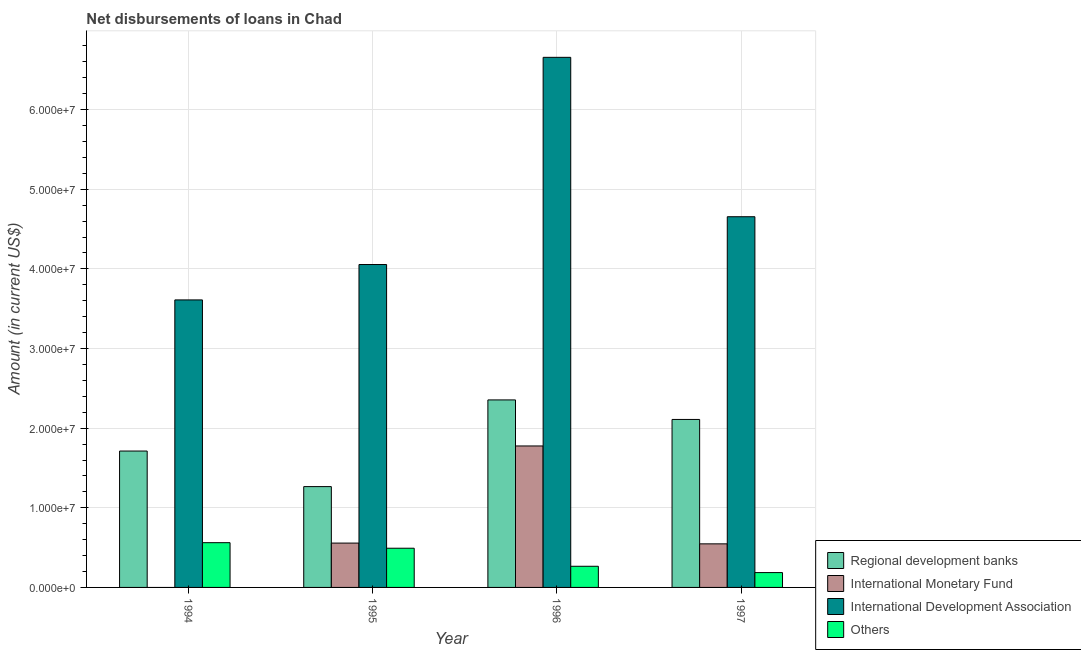Are the number of bars per tick equal to the number of legend labels?
Offer a very short reply. No. How many bars are there on the 4th tick from the left?
Your answer should be very brief. 4. How many bars are there on the 1st tick from the right?
Your response must be concise. 4. In how many cases, is the number of bars for a given year not equal to the number of legend labels?
Keep it short and to the point. 1. What is the amount of loan disimbursed by international development association in 1994?
Give a very brief answer. 3.61e+07. Across all years, what is the maximum amount of loan disimbursed by international development association?
Your response must be concise. 6.66e+07. Across all years, what is the minimum amount of loan disimbursed by international development association?
Keep it short and to the point. 3.61e+07. In which year was the amount of loan disimbursed by regional development banks maximum?
Provide a short and direct response. 1996. What is the total amount of loan disimbursed by international monetary fund in the graph?
Ensure brevity in your answer.  2.88e+07. What is the difference between the amount of loan disimbursed by international monetary fund in 1996 and that in 1997?
Your answer should be compact. 1.23e+07. What is the difference between the amount of loan disimbursed by international monetary fund in 1994 and the amount of loan disimbursed by international development association in 1996?
Your answer should be compact. -1.78e+07. What is the average amount of loan disimbursed by regional development banks per year?
Your response must be concise. 1.86e+07. In how many years, is the amount of loan disimbursed by other organisations greater than 28000000 US$?
Provide a succinct answer. 0. What is the ratio of the amount of loan disimbursed by other organisations in 1995 to that in 1997?
Your answer should be very brief. 2.64. Is the amount of loan disimbursed by regional development banks in 1995 less than that in 1996?
Your response must be concise. Yes. Is the difference between the amount of loan disimbursed by other organisations in 1996 and 1997 greater than the difference between the amount of loan disimbursed by international monetary fund in 1996 and 1997?
Provide a succinct answer. No. What is the difference between the highest and the second highest amount of loan disimbursed by international development association?
Provide a succinct answer. 2.00e+07. What is the difference between the highest and the lowest amount of loan disimbursed by regional development banks?
Keep it short and to the point. 1.09e+07. Is the sum of the amount of loan disimbursed by international development association in 1995 and 1996 greater than the maximum amount of loan disimbursed by regional development banks across all years?
Give a very brief answer. Yes. Is it the case that in every year, the sum of the amount of loan disimbursed by international monetary fund and amount of loan disimbursed by other organisations is greater than the sum of amount of loan disimbursed by regional development banks and amount of loan disimbursed by international development association?
Make the answer very short. No. How many bars are there?
Ensure brevity in your answer.  15. Are all the bars in the graph horizontal?
Give a very brief answer. No. What is the difference between two consecutive major ticks on the Y-axis?
Provide a succinct answer. 1.00e+07. Does the graph contain any zero values?
Give a very brief answer. Yes. Does the graph contain grids?
Keep it short and to the point. Yes. Where does the legend appear in the graph?
Offer a very short reply. Bottom right. How many legend labels are there?
Provide a short and direct response. 4. What is the title of the graph?
Your response must be concise. Net disbursements of loans in Chad. What is the label or title of the Y-axis?
Your response must be concise. Amount (in current US$). What is the Amount (in current US$) of Regional development banks in 1994?
Provide a short and direct response. 1.71e+07. What is the Amount (in current US$) in International Monetary Fund in 1994?
Give a very brief answer. 0. What is the Amount (in current US$) of International Development Association in 1994?
Your response must be concise. 3.61e+07. What is the Amount (in current US$) of Others in 1994?
Offer a terse response. 5.62e+06. What is the Amount (in current US$) in Regional development banks in 1995?
Offer a very short reply. 1.27e+07. What is the Amount (in current US$) in International Monetary Fund in 1995?
Ensure brevity in your answer.  5.57e+06. What is the Amount (in current US$) in International Development Association in 1995?
Your response must be concise. 4.05e+07. What is the Amount (in current US$) of Others in 1995?
Offer a terse response. 4.92e+06. What is the Amount (in current US$) in Regional development banks in 1996?
Ensure brevity in your answer.  2.35e+07. What is the Amount (in current US$) in International Monetary Fund in 1996?
Make the answer very short. 1.78e+07. What is the Amount (in current US$) in International Development Association in 1996?
Offer a very short reply. 6.66e+07. What is the Amount (in current US$) of Others in 1996?
Offer a terse response. 2.66e+06. What is the Amount (in current US$) of Regional development banks in 1997?
Your answer should be compact. 2.11e+07. What is the Amount (in current US$) of International Monetary Fund in 1997?
Your answer should be very brief. 5.47e+06. What is the Amount (in current US$) in International Development Association in 1997?
Provide a succinct answer. 4.66e+07. What is the Amount (in current US$) in Others in 1997?
Ensure brevity in your answer.  1.86e+06. Across all years, what is the maximum Amount (in current US$) of Regional development banks?
Offer a very short reply. 2.35e+07. Across all years, what is the maximum Amount (in current US$) in International Monetary Fund?
Make the answer very short. 1.78e+07. Across all years, what is the maximum Amount (in current US$) in International Development Association?
Give a very brief answer. 6.66e+07. Across all years, what is the maximum Amount (in current US$) in Others?
Your answer should be very brief. 5.62e+06. Across all years, what is the minimum Amount (in current US$) of Regional development banks?
Provide a succinct answer. 1.27e+07. Across all years, what is the minimum Amount (in current US$) in International Development Association?
Your answer should be very brief. 3.61e+07. Across all years, what is the minimum Amount (in current US$) of Others?
Offer a terse response. 1.86e+06. What is the total Amount (in current US$) of Regional development banks in the graph?
Your response must be concise. 7.44e+07. What is the total Amount (in current US$) in International Monetary Fund in the graph?
Your answer should be compact. 2.88e+07. What is the total Amount (in current US$) in International Development Association in the graph?
Offer a very short reply. 1.90e+08. What is the total Amount (in current US$) of Others in the graph?
Keep it short and to the point. 1.51e+07. What is the difference between the Amount (in current US$) in Regional development banks in 1994 and that in 1995?
Your response must be concise. 4.47e+06. What is the difference between the Amount (in current US$) in International Development Association in 1994 and that in 1995?
Provide a succinct answer. -4.44e+06. What is the difference between the Amount (in current US$) of Others in 1994 and that in 1995?
Ensure brevity in your answer.  6.97e+05. What is the difference between the Amount (in current US$) of Regional development banks in 1994 and that in 1996?
Make the answer very short. -6.42e+06. What is the difference between the Amount (in current US$) in International Development Association in 1994 and that in 1996?
Keep it short and to the point. -3.05e+07. What is the difference between the Amount (in current US$) of Others in 1994 and that in 1996?
Your answer should be very brief. 2.96e+06. What is the difference between the Amount (in current US$) of Regional development banks in 1994 and that in 1997?
Your response must be concise. -3.97e+06. What is the difference between the Amount (in current US$) of International Development Association in 1994 and that in 1997?
Keep it short and to the point. -1.04e+07. What is the difference between the Amount (in current US$) of Others in 1994 and that in 1997?
Provide a succinct answer. 3.76e+06. What is the difference between the Amount (in current US$) in Regional development banks in 1995 and that in 1996?
Ensure brevity in your answer.  -1.09e+07. What is the difference between the Amount (in current US$) of International Monetary Fund in 1995 and that in 1996?
Keep it short and to the point. -1.22e+07. What is the difference between the Amount (in current US$) of International Development Association in 1995 and that in 1996?
Give a very brief answer. -2.60e+07. What is the difference between the Amount (in current US$) of Others in 1995 and that in 1996?
Keep it short and to the point. 2.27e+06. What is the difference between the Amount (in current US$) of Regional development banks in 1995 and that in 1997?
Your answer should be very brief. -8.43e+06. What is the difference between the Amount (in current US$) of International Monetary Fund in 1995 and that in 1997?
Provide a succinct answer. 9.60e+04. What is the difference between the Amount (in current US$) in International Development Association in 1995 and that in 1997?
Provide a succinct answer. -6.00e+06. What is the difference between the Amount (in current US$) in Others in 1995 and that in 1997?
Ensure brevity in your answer.  3.06e+06. What is the difference between the Amount (in current US$) of Regional development banks in 1996 and that in 1997?
Your answer should be very brief. 2.45e+06. What is the difference between the Amount (in current US$) in International Monetary Fund in 1996 and that in 1997?
Your response must be concise. 1.23e+07. What is the difference between the Amount (in current US$) of International Development Association in 1996 and that in 1997?
Provide a succinct answer. 2.00e+07. What is the difference between the Amount (in current US$) in Others in 1996 and that in 1997?
Your answer should be very brief. 7.94e+05. What is the difference between the Amount (in current US$) of Regional development banks in 1994 and the Amount (in current US$) of International Monetary Fund in 1995?
Ensure brevity in your answer.  1.16e+07. What is the difference between the Amount (in current US$) in Regional development banks in 1994 and the Amount (in current US$) in International Development Association in 1995?
Offer a terse response. -2.34e+07. What is the difference between the Amount (in current US$) of Regional development banks in 1994 and the Amount (in current US$) of Others in 1995?
Your answer should be compact. 1.22e+07. What is the difference between the Amount (in current US$) of International Development Association in 1994 and the Amount (in current US$) of Others in 1995?
Provide a succinct answer. 3.12e+07. What is the difference between the Amount (in current US$) of Regional development banks in 1994 and the Amount (in current US$) of International Monetary Fund in 1996?
Offer a terse response. -6.37e+05. What is the difference between the Amount (in current US$) in Regional development banks in 1994 and the Amount (in current US$) in International Development Association in 1996?
Your answer should be compact. -4.94e+07. What is the difference between the Amount (in current US$) of Regional development banks in 1994 and the Amount (in current US$) of Others in 1996?
Your response must be concise. 1.45e+07. What is the difference between the Amount (in current US$) in International Development Association in 1994 and the Amount (in current US$) in Others in 1996?
Make the answer very short. 3.34e+07. What is the difference between the Amount (in current US$) in Regional development banks in 1994 and the Amount (in current US$) in International Monetary Fund in 1997?
Your answer should be compact. 1.17e+07. What is the difference between the Amount (in current US$) of Regional development banks in 1994 and the Amount (in current US$) of International Development Association in 1997?
Give a very brief answer. -2.94e+07. What is the difference between the Amount (in current US$) of Regional development banks in 1994 and the Amount (in current US$) of Others in 1997?
Provide a succinct answer. 1.53e+07. What is the difference between the Amount (in current US$) in International Development Association in 1994 and the Amount (in current US$) in Others in 1997?
Your answer should be very brief. 3.42e+07. What is the difference between the Amount (in current US$) of Regional development banks in 1995 and the Amount (in current US$) of International Monetary Fund in 1996?
Ensure brevity in your answer.  -5.10e+06. What is the difference between the Amount (in current US$) of Regional development banks in 1995 and the Amount (in current US$) of International Development Association in 1996?
Ensure brevity in your answer.  -5.39e+07. What is the difference between the Amount (in current US$) of Regional development banks in 1995 and the Amount (in current US$) of Others in 1996?
Ensure brevity in your answer.  1.00e+07. What is the difference between the Amount (in current US$) of International Monetary Fund in 1995 and the Amount (in current US$) of International Development Association in 1996?
Give a very brief answer. -6.10e+07. What is the difference between the Amount (in current US$) of International Monetary Fund in 1995 and the Amount (in current US$) of Others in 1996?
Give a very brief answer. 2.91e+06. What is the difference between the Amount (in current US$) in International Development Association in 1995 and the Amount (in current US$) in Others in 1996?
Keep it short and to the point. 3.79e+07. What is the difference between the Amount (in current US$) of Regional development banks in 1995 and the Amount (in current US$) of International Monetary Fund in 1997?
Your response must be concise. 7.19e+06. What is the difference between the Amount (in current US$) in Regional development banks in 1995 and the Amount (in current US$) in International Development Association in 1997?
Offer a very short reply. -3.39e+07. What is the difference between the Amount (in current US$) of Regional development banks in 1995 and the Amount (in current US$) of Others in 1997?
Give a very brief answer. 1.08e+07. What is the difference between the Amount (in current US$) of International Monetary Fund in 1995 and the Amount (in current US$) of International Development Association in 1997?
Offer a terse response. -4.10e+07. What is the difference between the Amount (in current US$) in International Monetary Fund in 1995 and the Amount (in current US$) in Others in 1997?
Offer a terse response. 3.70e+06. What is the difference between the Amount (in current US$) of International Development Association in 1995 and the Amount (in current US$) of Others in 1997?
Your answer should be compact. 3.87e+07. What is the difference between the Amount (in current US$) in Regional development banks in 1996 and the Amount (in current US$) in International Monetary Fund in 1997?
Keep it short and to the point. 1.81e+07. What is the difference between the Amount (in current US$) of Regional development banks in 1996 and the Amount (in current US$) of International Development Association in 1997?
Provide a succinct answer. -2.30e+07. What is the difference between the Amount (in current US$) of Regional development banks in 1996 and the Amount (in current US$) of Others in 1997?
Offer a very short reply. 2.17e+07. What is the difference between the Amount (in current US$) of International Monetary Fund in 1996 and the Amount (in current US$) of International Development Association in 1997?
Your response must be concise. -2.88e+07. What is the difference between the Amount (in current US$) of International Monetary Fund in 1996 and the Amount (in current US$) of Others in 1997?
Provide a succinct answer. 1.59e+07. What is the difference between the Amount (in current US$) in International Development Association in 1996 and the Amount (in current US$) in Others in 1997?
Your answer should be compact. 6.47e+07. What is the average Amount (in current US$) in Regional development banks per year?
Offer a very short reply. 1.86e+07. What is the average Amount (in current US$) of International Monetary Fund per year?
Make the answer very short. 7.20e+06. What is the average Amount (in current US$) in International Development Association per year?
Your answer should be compact. 4.74e+07. What is the average Amount (in current US$) of Others per year?
Keep it short and to the point. 3.77e+06. In the year 1994, what is the difference between the Amount (in current US$) of Regional development banks and Amount (in current US$) of International Development Association?
Your answer should be compact. -1.90e+07. In the year 1994, what is the difference between the Amount (in current US$) in Regional development banks and Amount (in current US$) in Others?
Your answer should be very brief. 1.15e+07. In the year 1994, what is the difference between the Amount (in current US$) in International Development Association and Amount (in current US$) in Others?
Keep it short and to the point. 3.05e+07. In the year 1995, what is the difference between the Amount (in current US$) in Regional development banks and Amount (in current US$) in International Monetary Fund?
Your answer should be very brief. 7.09e+06. In the year 1995, what is the difference between the Amount (in current US$) of Regional development banks and Amount (in current US$) of International Development Association?
Your answer should be compact. -2.79e+07. In the year 1995, what is the difference between the Amount (in current US$) in Regional development banks and Amount (in current US$) in Others?
Ensure brevity in your answer.  7.74e+06. In the year 1995, what is the difference between the Amount (in current US$) of International Monetary Fund and Amount (in current US$) of International Development Association?
Provide a short and direct response. -3.50e+07. In the year 1995, what is the difference between the Amount (in current US$) of International Monetary Fund and Amount (in current US$) of Others?
Provide a succinct answer. 6.45e+05. In the year 1995, what is the difference between the Amount (in current US$) of International Development Association and Amount (in current US$) of Others?
Provide a short and direct response. 3.56e+07. In the year 1996, what is the difference between the Amount (in current US$) of Regional development banks and Amount (in current US$) of International Monetary Fund?
Give a very brief answer. 5.78e+06. In the year 1996, what is the difference between the Amount (in current US$) of Regional development banks and Amount (in current US$) of International Development Association?
Your response must be concise. -4.30e+07. In the year 1996, what is the difference between the Amount (in current US$) of Regional development banks and Amount (in current US$) of Others?
Your answer should be very brief. 2.09e+07. In the year 1996, what is the difference between the Amount (in current US$) of International Monetary Fund and Amount (in current US$) of International Development Association?
Give a very brief answer. -4.88e+07. In the year 1996, what is the difference between the Amount (in current US$) in International Monetary Fund and Amount (in current US$) in Others?
Your answer should be very brief. 1.51e+07. In the year 1996, what is the difference between the Amount (in current US$) in International Development Association and Amount (in current US$) in Others?
Your answer should be very brief. 6.39e+07. In the year 1997, what is the difference between the Amount (in current US$) in Regional development banks and Amount (in current US$) in International Monetary Fund?
Your answer should be very brief. 1.56e+07. In the year 1997, what is the difference between the Amount (in current US$) of Regional development banks and Amount (in current US$) of International Development Association?
Provide a succinct answer. -2.55e+07. In the year 1997, what is the difference between the Amount (in current US$) in Regional development banks and Amount (in current US$) in Others?
Provide a short and direct response. 1.92e+07. In the year 1997, what is the difference between the Amount (in current US$) in International Monetary Fund and Amount (in current US$) in International Development Association?
Your answer should be compact. -4.11e+07. In the year 1997, what is the difference between the Amount (in current US$) in International Monetary Fund and Amount (in current US$) in Others?
Keep it short and to the point. 3.61e+06. In the year 1997, what is the difference between the Amount (in current US$) of International Development Association and Amount (in current US$) of Others?
Offer a very short reply. 4.47e+07. What is the ratio of the Amount (in current US$) in Regional development banks in 1994 to that in 1995?
Ensure brevity in your answer.  1.35. What is the ratio of the Amount (in current US$) of International Development Association in 1994 to that in 1995?
Offer a terse response. 0.89. What is the ratio of the Amount (in current US$) in Others in 1994 to that in 1995?
Provide a succinct answer. 1.14. What is the ratio of the Amount (in current US$) of Regional development banks in 1994 to that in 1996?
Ensure brevity in your answer.  0.73. What is the ratio of the Amount (in current US$) in International Development Association in 1994 to that in 1996?
Your response must be concise. 0.54. What is the ratio of the Amount (in current US$) in Others in 1994 to that in 1996?
Give a very brief answer. 2.12. What is the ratio of the Amount (in current US$) in Regional development banks in 1994 to that in 1997?
Your answer should be compact. 0.81. What is the ratio of the Amount (in current US$) of International Development Association in 1994 to that in 1997?
Keep it short and to the point. 0.78. What is the ratio of the Amount (in current US$) of Others in 1994 to that in 1997?
Keep it short and to the point. 3.02. What is the ratio of the Amount (in current US$) in Regional development banks in 1995 to that in 1996?
Make the answer very short. 0.54. What is the ratio of the Amount (in current US$) in International Monetary Fund in 1995 to that in 1996?
Give a very brief answer. 0.31. What is the ratio of the Amount (in current US$) in International Development Association in 1995 to that in 1996?
Provide a succinct answer. 0.61. What is the ratio of the Amount (in current US$) in Others in 1995 to that in 1996?
Provide a short and direct response. 1.85. What is the ratio of the Amount (in current US$) in Regional development banks in 1995 to that in 1997?
Offer a very short reply. 0.6. What is the ratio of the Amount (in current US$) in International Monetary Fund in 1995 to that in 1997?
Keep it short and to the point. 1.02. What is the ratio of the Amount (in current US$) of International Development Association in 1995 to that in 1997?
Your response must be concise. 0.87. What is the ratio of the Amount (in current US$) in Others in 1995 to that in 1997?
Provide a short and direct response. 2.64. What is the ratio of the Amount (in current US$) in Regional development banks in 1996 to that in 1997?
Give a very brief answer. 1.12. What is the ratio of the Amount (in current US$) in International Monetary Fund in 1996 to that in 1997?
Make the answer very short. 3.25. What is the ratio of the Amount (in current US$) in International Development Association in 1996 to that in 1997?
Ensure brevity in your answer.  1.43. What is the ratio of the Amount (in current US$) of Others in 1996 to that in 1997?
Offer a very short reply. 1.43. What is the difference between the highest and the second highest Amount (in current US$) in Regional development banks?
Keep it short and to the point. 2.45e+06. What is the difference between the highest and the second highest Amount (in current US$) of International Monetary Fund?
Give a very brief answer. 1.22e+07. What is the difference between the highest and the second highest Amount (in current US$) of International Development Association?
Provide a succinct answer. 2.00e+07. What is the difference between the highest and the second highest Amount (in current US$) of Others?
Your answer should be very brief. 6.97e+05. What is the difference between the highest and the lowest Amount (in current US$) of Regional development banks?
Your response must be concise. 1.09e+07. What is the difference between the highest and the lowest Amount (in current US$) of International Monetary Fund?
Provide a short and direct response. 1.78e+07. What is the difference between the highest and the lowest Amount (in current US$) in International Development Association?
Your answer should be very brief. 3.05e+07. What is the difference between the highest and the lowest Amount (in current US$) of Others?
Offer a very short reply. 3.76e+06. 